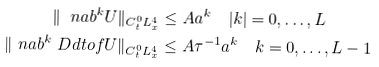Convert formula to latex. <formula><loc_0><loc_0><loc_500><loc_500>\| \ n a b ^ { k } U \| _ { C ^ { 0 } _ { t } L _ { x } ^ { 4 } } & \leq A \L a ^ { k } \quad | k | = 0 , \dots , L \\ \| \ n a b ^ { k } \ D d t o f { U } \| _ { C ^ { 0 } _ { t } L _ { x } ^ { 4 } } & \leq A \tau ^ { - 1 } \L a ^ { k } \quad k = 0 , \dots , L - 1</formula> 